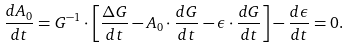<formula> <loc_0><loc_0><loc_500><loc_500>\frac { d A _ { 0 } } { d t } = G ^ { - 1 } \cdot \left [ \frac { \Delta G } { d t } - A _ { 0 } \cdot \frac { d G } { d t } - \epsilon \cdot \frac { d G } { d t } \right ] - \frac { d \epsilon } { d t } = 0 .</formula> 